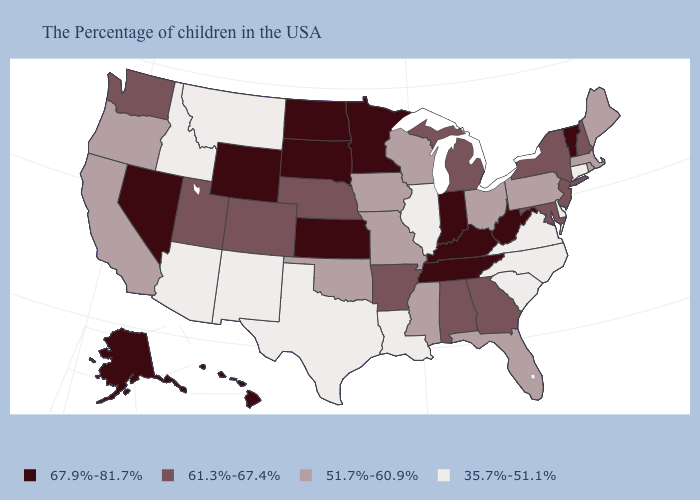Is the legend a continuous bar?
Be succinct. No. What is the value of Texas?
Write a very short answer. 35.7%-51.1%. Does Louisiana have the same value as New Mexico?
Concise answer only. Yes. What is the value of Michigan?
Answer briefly. 61.3%-67.4%. Does the map have missing data?
Write a very short answer. No. What is the highest value in the MidWest ?
Answer briefly. 67.9%-81.7%. Does Oklahoma have the same value as Nebraska?
Short answer required. No. What is the highest value in states that border South Carolina?
Keep it brief. 61.3%-67.4%. Among the states that border New Hampshire , which have the lowest value?
Answer briefly. Maine, Massachusetts. Name the states that have a value in the range 35.7%-51.1%?
Give a very brief answer. Connecticut, Delaware, Virginia, North Carolina, South Carolina, Illinois, Louisiana, Texas, New Mexico, Montana, Arizona, Idaho. Among the states that border Alabama , does Mississippi have the lowest value?
Answer briefly. Yes. Among the states that border Louisiana , does Arkansas have the lowest value?
Answer briefly. No. What is the value of Oklahoma?
Write a very short answer. 51.7%-60.9%. What is the value of Pennsylvania?
Be succinct. 51.7%-60.9%. 